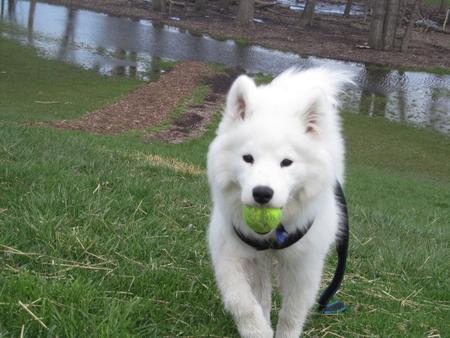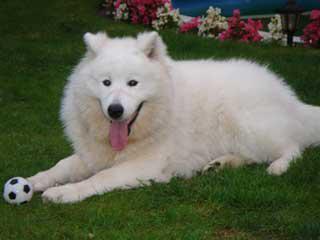The first image is the image on the left, the second image is the image on the right. Examine the images to the left and right. Is the description "There is a ball or a backpack in atleast one of the pictures." accurate? Answer yes or no. Yes. The first image is the image on the left, the second image is the image on the right. Considering the images on both sides, is "At least one dog is sitting and one image has exactly 2 dogs." valid? Answer yes or no. No. 